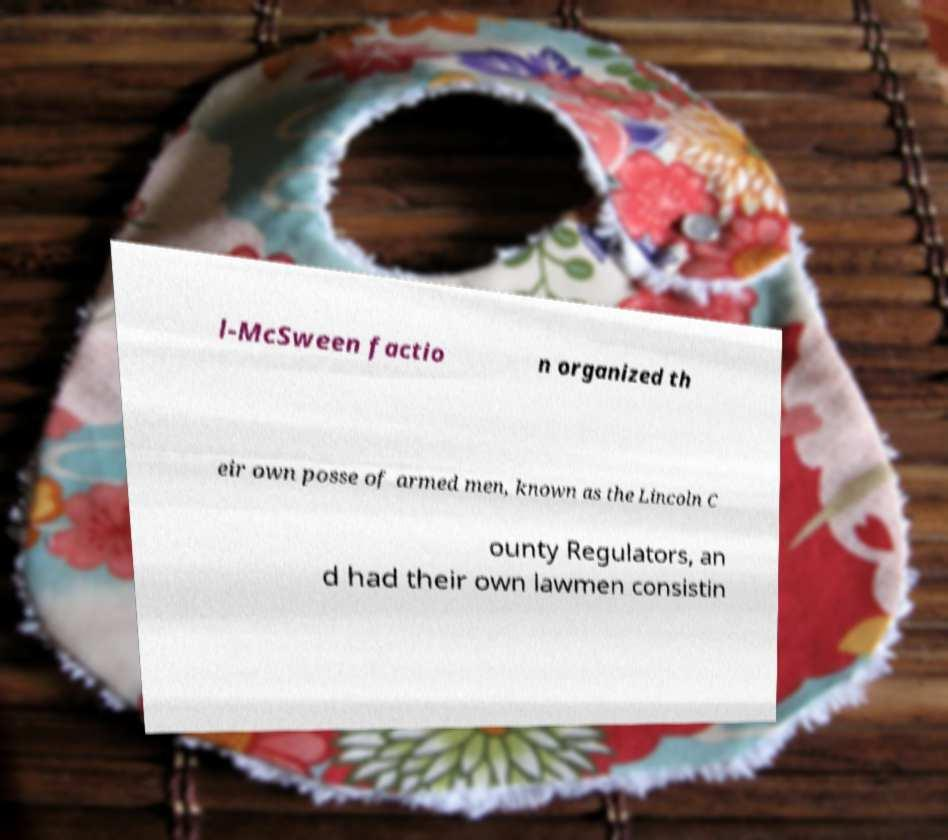Can you accurately transcribe the text from the provided image for me? l-McSween factio n organized th eir own posse of armed men, known as the Lincoln C ounty Regulators, an d had their own lawmen consistin 